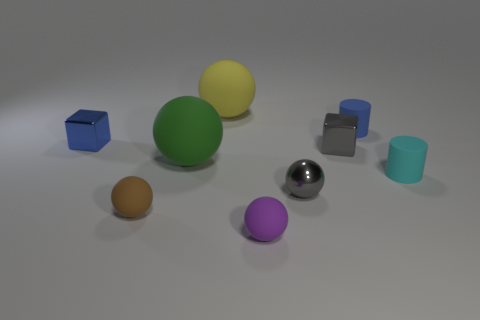Subtract all tiny gray metallic balls. How many balls are left? 4 Subtract all brown spheres. How many spheres are left? 4 Subtract all yellow cubes. Subtract all gray spheres. How many cubes are left? 2 Add 1 big gray metallic blocks. How many objects exist? 10 Subtract all cubes. How many objects are left? 7 Subtract 0 purple cylinders. How many objects are left? 9 Subtract all gray metal spheres. Subtract all small brown things. How many objects are left? 7 Add 9 green matte balls. How many green matte balls are left? 10 Add 2 small purple shiny objects. How many small purple shiny objects exist? 2 